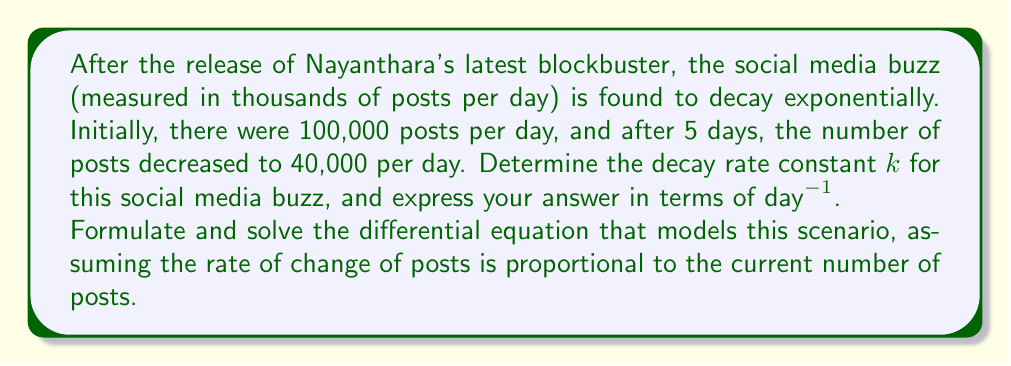Solve this math problem. Let's approach this step-by-step:

1) Let $P(t)$ be the number of posts (in thousands) at time $t$ (in days).

2) We're told that the decay is exponential, which means it follows the form:
   $$P(t) = P_0 e^{-kt}$$
   where $P_0$ is the initial number of posts and $k$ is the decay rate constant.

3) We're given two points:
   At $t=0$, $P(0) = 100$
   At $t=5$, $P(5) = 40$

4) Let's use these points in our exponential decay equation:
   $$100 = P_0 e^{-k(0)}$$
   $$40 = P_0 e^{-k(5)}$$

5) From the first equation, we can see that $P_0 = 100$.

6) Now, let's use this in the second equation:
   $$40 = 100 e^{-5k}$$

7) Divide both sides by 100:
   $$0.4 = e^{-5k}$$

8) Take the natural log of both sides:
   $$\ln(0.4) = -5k$$

9) Solve for $k$:
   $$k = -\frac{\ln(0.4)}{5} \approx 0.1832 \text{ day}^{-1}$$

This decay rate constant $k$ can be interpreted as the fraction of remaining posts that decay per day.

To verify, we can formulate the differential equation:
$$\frac{dP}{dt} = -kP$$
This equation states that the rate of change of posts is proportional to the current number of posts, with $k$ as the proportionality constant.
Answer: The decay rate constant $k$ is approximately $0.1832 \text{ day}^{-1}$. 